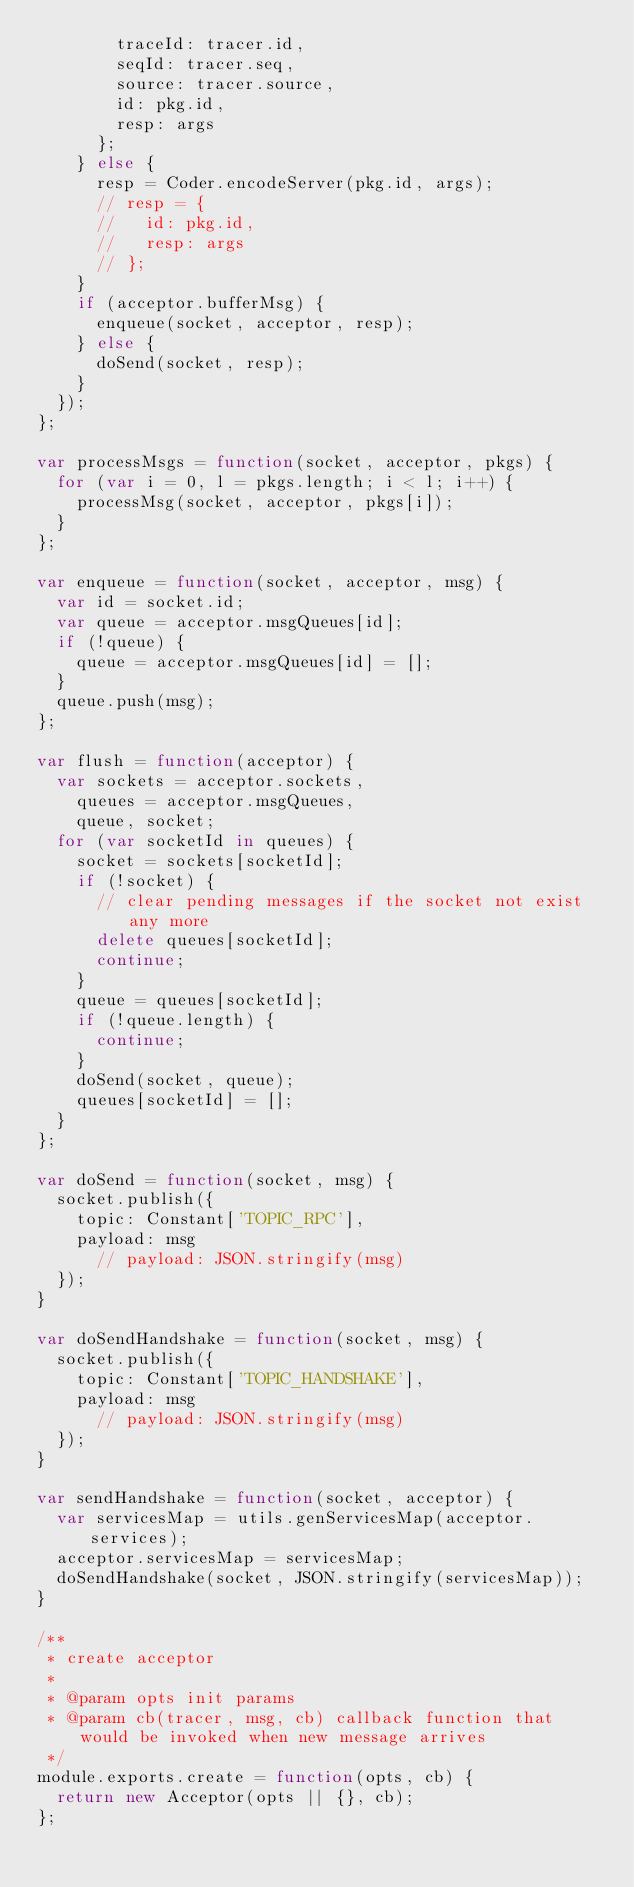Convert code to text. <code><loc_0><loc_0><loc_500><loc_500><_JavaScript_>        traceId: tracer.id,
        seqId: tracer.seq,
        source: tracer.source,
        id: pkg.id,
        resp: args
      };
    } else {
      resp = Coder.encodeServer(pkg.id, args);
      // resp = {
      //   id: pkg.id,
      //   resp: args
      // };
    }
    if (acceptor.bufferMsg) {
      enqueue(socket, acceptor, resp);
    } else {
      doSend(socket, resp);
    }
  });
};

var processMsgs = function(socket, acceptor, pkgs) {
  for (var i = 0, l = pkgs.length; i < l; i++) {
    processMsg(socket, acceptor, pkgs[i]);
  }
};

var enqueue = function(socket, acceptor, msg) {
  var id = socket.id;
  var queue = acceptor.msgQueues[id];
  if (!queue) {
    queue = acceptor.msgQueues[id] = [];
  }
  queue.push(msg);
};

var flush = function(acceptor) {
  var sockets = acceptor.sockets,
    queues = acceptor.msgQueues,
    queue, socket;
  for (var socketId in queues) {
    socket = sockets[socketId];
    if (!socket) {
      // clear pending messages if the socket not exist any more
      delete queues[socketId];
      continue;
    }
    queue = queues[socketId];
    if (!queue.length) {
      continue;
    }
    doSend(socket, queue);
    queues[socketId] = [];
  }
};

var doSend = function(socket, msg) {
  socket.publish({
    topic: Constant['TOPIC_RPC'],
    payload: msg
      // payload: JSON.stringify(msg)
  });
}

var doSendHandshake = function(socket, msg) {
  socket.publish({
    topic: Constant['TOPIC_HANDSHAKE'],
    payload: msg
      // payload: JSON.stringify(msg)
  });
}

var sendHandshake = function(socket, acceptor) {
  var servicesMap = utils.genServicesMap(acceptor.services);
  acceptor.servicesMap = servicesMap;
  doSendHandshake(socket, JSON.stringify(servicesMap));
}

/**
 * create acceptor
 *
 * @param opts init params
 * @param cb(tracer, msg, cb) callback function that would be invoked when new message arrives
 */
module.exports.create = function(opts, cb) {
  return new Acceptor(opts || {}, cb);
};</code> 